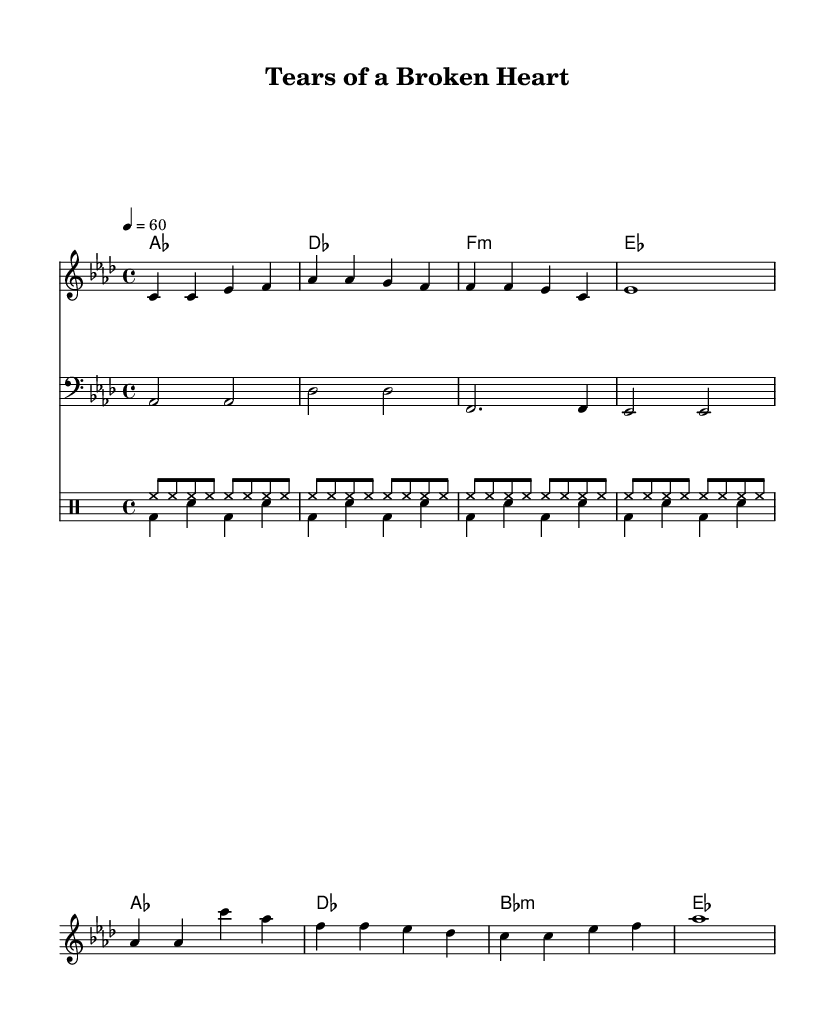What is the key signature of this music? The key signature is based on the "aes" note, which indicates that it has three flats: B♭, E♭, and A♭. Hence, the key signature is A♭ major.
Answer: A♭ major What is the time signature of this music? The time signature is indicated in the initial part of the score, where "4/4" is shown. This means there are four beats in each measure.
Answer: 4/4 What is the tempo marking for this piece? The tempo is specified as "4 = 60," meaning there are 60 quarter note beats per minute.
Answer: 60 How many measures are in the verse? The verse consists of four lines of music with a total of four measures each, which gives 4 measures in the verse.
Answer: 4 What is the primary theme of the lyrics in the chorus? The chorus lyrics emphasize sadness and longing, specifically mentioning "Tears of a broken heart," which reflects the theme of heartbreak.
Answer: Heartbreak What type of drum patterns are used in this piece? The piece features two different drum patterns: "drumsUp" which consists mainly of hi-hat hits and "drumsDown" which includes bass drum and snare hits.
Answer: Two patterns What is the mood conveyed by the melody and chords in this soul ballad? The melody and harmony, with their rich chords and emotive lyrics, convey a deep sense of melancholy and longing, typical of soul ballads focused on love and heartbreak.
Answer: Melancholy 